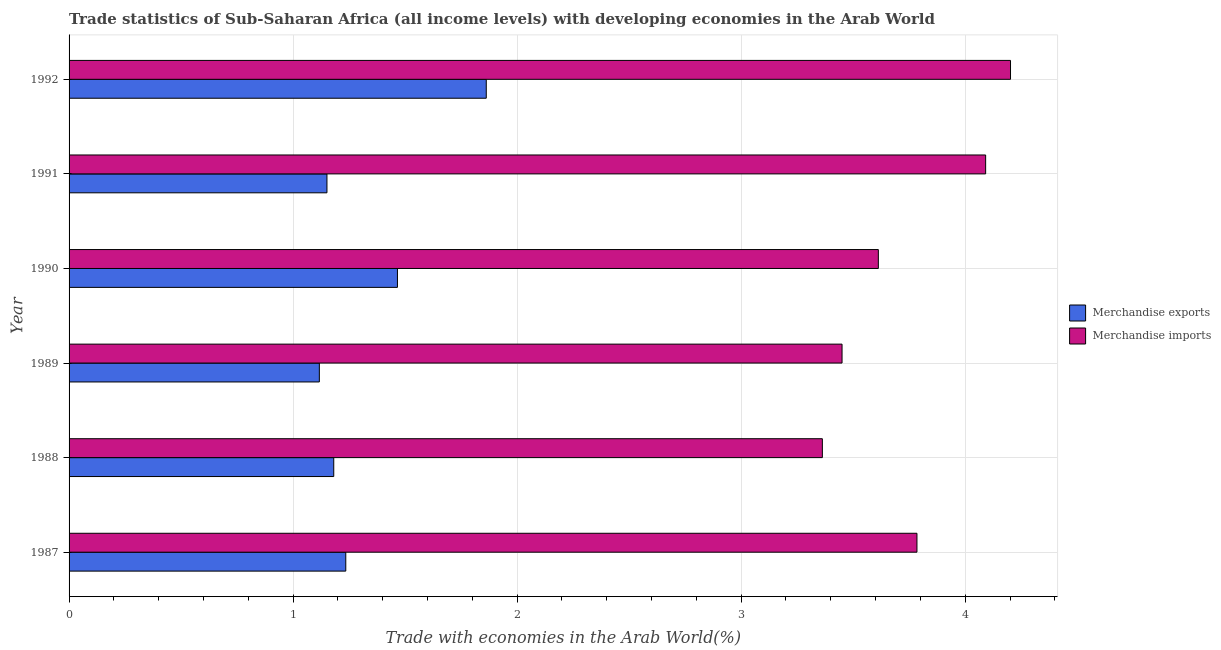How many groups of bars are there?
Your response must be concise. 6. Are the number of bars per tick equal to the number of legend labels?
Keep it short and to the point. Yes. How many bars are there on the 5th tick from the bottom?
Your response must be concise. 2. In how many cases, is the number of bars for a given year not equal to the number of legend labels?
Give a very brief answer. 0. What is the merchandise exports in 1988?
Make the answer very short. 1.18. Across all years, what is the maximum merchandise imports?
Your response must be concise. 4.2. Across all years, what is the minimum merchandise imports?
Make the answer very short. 3.36. What is the total merchandise imports in the graph?
Ensure brevity in your answer.  22.5. What is the difference between the merchandise imports in 1987 and that in 1988?
Provide a short and direct response. 0.42. What is the difference between the merchandise exports in 1990 and the merchandise imports in 1991?
Give a very brief answer. -2.63. What is the average merchandise exports per year?
Your answer should be compact. 1.33. In the year 1988, what is the difference between the merchandise imports and merchandise exports?
Your response must be concise. 2.18. In how many years, is the merchandise exports greater than 2.6 %?
Provide a succinct answer. 0. What is the ratio of the merchandise imports in 1987 to that in 1988?
Offer a terse response. 1.13. Is the merchandise imports in 1988 less than that in 1989?
Provide a short and direct response. Yes. Is the difference between the merchandise exports in 1987 and 1990 greater than the difference between the merchandise imports in 1987 and 1990?
Your answer should be compact. No. What is the difference between the highest and the second highest merchandise imports?
Offer a very short reply. 0.11. What is the difference between the highest and the lowest merchandise imports?
Ensure brevity in your answer.  0.84. What does the 2nd bar from the top in 1987 represents?
Offer a very short reply. Merchandise exports. What does the 2nd bar from the bottom in 1987 represents?
Ensure brevity in your answer.  Merchandise imports. How many bars are there?
Your answer should be very brief. 12. Are the values on the major ticks of X-axis written in scientific E-notation?
Make the answer very short. No. Does the graph contain any zero values?
Ensure brevity in your answer.  No. Does the graph contain grids?
Keep it short and to the point. Yes. How many legend labels are there?
Offer a terse response. 2. What is the title of the graph?
Offer a very short reply. Trade statistics of Sub-Saharan Africa (all income levels) with developing economies in the Arab World. What is the label or title of the X-axis?
Your response must be concise. Trade with economies in the Arab World(%). What is the label or title of the Y-axis?
Provide a short and direct response. Year. What is the Trade with economies in the Arab World(%) in Merchandise exports in 1987?
Make the answer very short. 1.24. What is the Trade with economies in the Arab World(%) in Merchandise imports in 1987?
Offer a terse response. 3.78. What is the Trade with economies in the Arab World(%) in Merchandise exports in 1988?
Your answer should be compact. 1.18. What is the Trade with economies in the Arab World(%) in Merchandise imports in 1988?
Offer a terse response. 3.36. What is the Trade with economies in the Arab World(%) in Merchandise exports in 1989?
Your response must be concise. 1.12. What is the Trade with economies in the Arab World(%) in Merchandise imports in 1989?
Offer a very short reply. 3.45. What is the Trade with economies in the Arab World(%) in Merchandise exports in 1990?
Your answer should be very brief. 1.47. What is the Trade with economies in the Arab World(%) in Merchandise imports in 1990?
Ensure brevity in your answer.  3.61. What is the Trade with economies in the Arab World(%) of Merchandise exports in 1991?
Give a very brief answer. 1.15. What is the Trade with economies in the Arab World(%) of Merchandise imports in 1991?
Provide a short and direct response. 4.09. What is the Trade with economies in the Arab World(%) in Merchandise exports in 1992?
Give a very brief answer. 1.86. What is the Trade with economies in the Arab World(%) in Merchandise imports in 1992?
Your answer should be very brief. 4.2. Across all years, what is the maximum Trade with economies in the Arab World(%) of Merchandise exports?
Make the answer very short. 1.86. Across all years, what is the maximum Trade with economies in the Arab World(%) of Merchandise imports?
Your answer should be very brief. 4.2. Across all years, what is the minimum Trade with economies in the Arab World(%) in Merchandise exports?
Provide a short and direct response. 1.12. Across all years, what is the minimum Trade with economies in the Arab World(%) of Merchandise imports?
Offer a very short reply. 3.36. What is the total Trade with economies in the Arab World(%) of Merchandise exports in the graph?
Your answer should be compact. 8.01. What is the total Trade with economies in the Arab World(%) in Merchandise imports in the graph?
Provide a succinct answer. 22.5. What is the difference between the Trade with economies in the Arab World(%) in Merchandise exports in 1987 and that in 1988?
Your answer should be very brief. 0.05. What is the difference between the Trade with economies in the Arab World(%) of Merchandise imports in 1987 and that in 1988?
Provide a succinct answer. 0.42. What is the difference between the Trade with economies in the Arab World(%) of Merchandise exports in 1987 and that in 1989?
Offer a terse response. 0.12. What is the difference between the Trade with economies in the Arab World(%) of Merchandise imports in 1987 and that in 1989?
Offer a very short reply. 0.33. What is the difference between the Trade with economies in the Arab World(%) of Merchandise exports in 1987 and that in 1990?
Offer a very short reply. -0.23. What is the difference between the Trade with economies in the Arab World(%) of Merchandise imports in 1987 and that in 1990?
Your answer should be compact. 0.17. What is the difference between the Trade with economies in the Arab World(%) of Merchandise exports in 1987 and that in 1991?
Keep it short and to the point. 0.08. What is the difference between the Trade with economies in the Arab World(%) of Merchandise imports in 1987 and that in 1991?
Your answer should be very brief. -0.31. What is the difference between the Trade with economies in the Arab World(%) of Merchandise exports in 1987 and that in 1992?
Your response must be concise. -0.63. What is the difference between the Trade with economies in the Arab World(%) of Merchandise imports in 1987 and that in 1992?
Your answer should be very brief. -0.42. What is the difference between the Trade with economies in the Arab World(%) of Merchandise exports in 1988 and that in 1989?
Offer a very short reply. 0.06. What is the difference between the Trade with economies in the Arab World(%) in Merchandise imports in 1988 and that in 1989?
Keep it short and to the point. -0.09. What is the difference between the Trade with economies in the Arab World(%) in Merchandise exports in 1988 and that in 1990?
Keep it short and to the point. -0.28. What is the difference between the Trade with economies in the Arab World(%) in Merchandise imports in 1988 and that in 1990?
Offer a very short reply. -0.25. What is the difference between the Trade with economies in the Arab World(%) in Merchandise exports in 1988 and that in 1991?
Keep it short and to the point. 0.03. What is the difference between the Trade with economies in the Arab World(%) in Merchandise imports in 1988 and that in 1991?
Provide a short and direct response. -0.73. What is the difference between the Trade with economies in the Arab World(%) of Merchandise exports in 1988 and that in 1992?
Your answer should be very brief. -0.68. What is the difference between the Trade with economies in the Arab World(%) of Merchandise imports in 1988 and that in 1992?
Ensure brevity in your answer.  -0.84. What is the difference between the Trade with economies in the Arab World(%) in Merchandise exports in 1989 and that in 1990?
Provide a short and direct response. -0.35. What is the difference between the Trade with economies in the Arab World(%) of Merchandise imports in 1989 and that in 1990?
Ensure brevity in your answer.  -0.16. What is the difference between the Trade with economies in the Arab World(%) of Merchandise exports in 1989 and that in 1991?
Provide a succinct answer. -0.03. What is the difference between the Trade with economies in the Arab World(%) in Merchandise imports in 1989 and that in 1991?
Your response must be concise. -0.64. What is the difference between the Trade with economies in the Arab World(%) of Merchandise exports in 1989 and that in 1992?
Your answer should be compact. -0.74. What is the difference between the Trade with economies in the Arab World(%) in Merchandise imports in 1989 and that in 1992?
Provide a succinct answer. -0.75. What is the difference between the Trade with economies in the Arab World(%) in Merchandise exports in 1990 and that in 1991?
Your answer should be very brief. 0.31. What is the difference between the Trade with economies in the Arab World(%) of Merchandise imports in 1990 and that in 1991?
Your answer should be very brief. -0.48. What is the difference between the Trade with economies in the Arab World(%) of Merchandise exports in 1990 and that in 1992?
Make the answer very short. -0.4. What is the difference between the Trade with economies in the Arab World(%) of Merchandise imports in 1990 and that in 1992?
Offer a terse response. -0.59. What is the difference between the Trade with economies in the Arab World(%) of Merchandise exports in 1991 and that in 1992?
Your response must be concise. -0.71. What is the difference between the Trade with economies in the Arab World(%) in Merchandise imports in 1991 and that in 1992?
Offer a very short reply. -0.11. What is the difference between the Trade with economies in the Arab World(%) of Merchandise exports in 1987 and the Trade with economies in the Arab World(%) of Merchandise imports in 1988?
Your answer should be very brief. -2.13. What is the difference between the Trade with economies in the Arab World(%) in Merchandise exports in 1987 and the Trade with economies in the Arab World(%) in Merchandise imports in 1989?
Offer a terse response. -2.22. What is the difference between the Trade with economies in the Arab World(%) of Merchandise exports in 1987 and the Trade with economies in the Arab World(%) of Merchandise imports in 1990?
Provide a short and direct response. -2.38. What is the difference between the Trade with economies in the Arab World(%) of Merchandise exports in 1987 and the Trade with economies in the Arab World(%) of Merchandise imports in 1991?
Provide a short and direct response. -2.86. What is the difference between the Trade with economies in the Arab World(%) in Merchandise exports in 1987 and the Trade with economies in the Arab World(%) in Merchandise imports in 1992?
Provide a short and direct response. -2.97. What is the difference between the Trade with economies in the Arab World(%) of Merchandise exports in 1988 and the Trade with economies in the Arab World(%) of Merchandise imports in 1989?
Keep it short and to the point. -2.27. What is the difference between the Trade with economies in the Arab World(%) of Merchandise exports in 1988 and the Trade with economies in the Arab World(%) of Merchandise imports in 1990?
Provide a short and direct response. -2.43. What is the difference between the Trade with economies in the Arab World(%) of Merchandise exports in 1988 and the Trade with economies in the Arab World(%) of Merchandise imports in 1991?
Ensure brevity in your answer.  -2.91. What is the difference between the Trade with economies in the Arab World(%) of Merchandise exports in 1988 and the Trade with economies in the Arab World(%) of Merchandise imports in 1992?
Your answer should be compact. -3.02. What is the difference between the Trade with economies in the Arab World(%) of Merchandise exports in 1989 and the Trade with economies in the Arab World(%) of Merchandise imports in 1990?
Provide a short and direct response. -2.5. What is the difference between the Trade with economies in the Arab World(%) in Merchandise exports in 1989 and the Trade with economies in the Arab World(%) in Merchandise imports in 1991?
Make the answer very short. -2.97. What is the difference between the Trade with economies in the Arab World(%) in Merchandise exports in 1989 and the Trade with economies in the Arab World(%) in Merchandise imports in 1992?
Your answer should be very brief. -3.09. What is the difference between the Trade with economies in the Arab World(%) in Merchandise exports in 1990 and the Trade with economies in the Arab World(%) in Merchandise imports in 1991?
Your answer should be very brief. -2.63. What is the difference between the Trade with economies in the Arab World(%) in Merchandise exports in 1990 and the Trade with economies in the Arab World(%) in Merchandise imports in 1992?
Provide a short and direct response. -2.74. What is the difference between the Trade with economies in the Arab World(%) in Merchandise exports in 1991 and the Trade with economies in the Arab World(%) in Merchandise imports in 1992?
Provide a succinct answer. -3.05. What is the average Trade with economies in the Arab World(%) in Merchandise exports per year?
Offer a very short reply. 1.34. What is the average Trade with economies in the Arab World(%) in Merchandise imports per year?
Your answer should be compact. 3.75. In the year 1987, what is the difference between the Trade with economies in the Arab World(%) in Merchandise exports and Trade with economies in the Arab World(%) in Merchandise imports?
Give a very brief answer. -2.55. In the year 1988, what is the difference between the Trade with economies in the Arab World(%) in Merchandise exports and Trade with economies in the Arab World(%) in Merchandise imports?
Give a very brief answer. -2.18. In the year 1989, what is the difference between the Trade with economies in the Arab World(%) of Merchandise exports and Trade with economies in the Arab World(%) of Merchandise imports?
Give a very brief answer. -2.33. In the year 1990, what is the difference between the Trade with economies in the Arab World(%) of Merchandise exports and Trade with economies in the Arab World(%) of Merchandise imports?
Your answer should be very brief. -2.15. In the year 1991, what is the difference between the Trade with economies in the Arab World(%) in Merchandise exports and Trade with economies in the Arab World(%) in Merchandise imports?
Your answer should be very brief. -2.94. In the year 1992, what is the difference between the Trade with economies in the Arab World(%) in Merchandise exports and Trade with economies in the Arab World(%) in Merchandise imports?
Keep it short and to the point. -2.34. What is the ratio of the Trade with economies in the Arab World(%) in Merchandise exports in 1987 to that in 1988?
Your response must be concise. 1.05. What is the ratio of the Trade with economies in the Arab World(%) of Merchandise imports in 1987 to that in 1988?
Keep it short and to the point. 1.13. What is the ratio of the Trade with economies in the Arab World(%) in Merchandise exports in 1987 to that in 1989?
Your answer should be compact. 1.11. What is the ratio of the Trade with economies in the Arab World(%) in Merchandise imports in 1987 to that in 1989?
Make the answer very short. 1.1. What is the ratio of the Trade with economies in the Arab World(%) in Merchandise exports in 1987 to that in 1990?
Provide a short and direct response. 0.84. What is the ratio of the Trade with economies in the Arab World(%) of Merchandise imports in 1987 to that in 1990?
Your answer should be very brief. 1.05. What is the ratio of the Trade with economies in the Arab World(%) in Merchandise exports in 1987 to that in 1991?
Provide a succinct answer. 1.07. What is the ratio of the Trade with economies in the Arab World(%) of Merchandise imports in 1987 to that in 1991?
Give a very brief answer. 0.93. What is the ratio of the Trade with economies in the Arab World(%) in Merchandise exports in 1987 to that in 1992?
Your answer should be compact. 0.66. What is the ratio of the Trade with economies in the Arab World(%) in Merchandise imports in 1987 to that in 1992?
Provide a succinct answer. 0.9. What is the ratio of the Trade with economies in the Arab World(%) of Merchandise exports in 1988 to that in 1989?
Keep it short and to the point. 1.06. What is the ratio of the Trade with economies in the Arab World(%) of Merchandise imports in 1988 to that in 1989?
Your answer should be very brief. 0.97. What is the ratio of the Trade with economies in the Arab World(%) in Merchandise exports in 1988 to that in 1990?
Make the answer very short. 0.81. What is the ratio of the Trade with economies in the Arab World(%) of Merchandise imports in 1988 to that in 1990?
Give a very brief answer. 0.93. What is the ratio of the Trade with economies in the Arab World(%) in Merchandise exports in 1988 to that in 1991?
Offer a very short reply. 1.03. What is the ratio of the Trade with economies in the Arab World(%) of Merchandise imports in 1988 to that in 1991?
Your answer should be very brief. 0.82. What is the ratio of the Trade with economies in the Arab World(%) of Merchandise exports in 1988 to that in 1992?
Give a very brief answer. 0.63. What is the ratio of the Trade with economies in the Arab World(%) in Merchandise imports in 1988 to that in 1992?
Keep it short and to the point. 0.8. What is the ratio of the Trade with economies in the Arab World(%) of Merchandise exports in 1989 to that in 1990?
Give a very brief answer. 0.76. What is the ratio of the Trade with economies in the Arab World(%) of Merchandise imports in 1989 to that in 1990?
Give a very brief answer. 0.96. What is the ratio of the Trade with economies in the Arab World(%) of Merchandise exports in 1989 to that in 1991?
Your answer should be compact. 0.97. What is the ratio of the Trade with economies in the Arab World(%) of Merchandise imports in 1989 to that in 1991?
Your answer should be very brief. 0.84. What is the ratio of the Trade with economies in the Arab World(%) of Merchandise exports in 1989 to that in 1992?
Give a very brief answer. 0.6. What is the ratio of the Trade with economies in the Arab World(%) of Merchandise imports in 1989 to that in 1992?
Provide a short and direct response. 0.82. What is the ratio of the Trade with economies in the Arab World(%) of Merchandise exports in 1990 to that in 1991?
Provide a short and direct response. 1.27. What is the ratio of the Trade with economies in the Arab World(%) of Merchandise imports in 1990 to that in 1991?
Offer a very short reply. 0.88. What is the ratio of the Trade with economies in the Arab World(%) in Merchandise exports in 1990 to that in 1992?
Offer a very short reply. 0.79. What is the ratio of the Trade with economies in the Arab World(%) in Merchandise imports in 1990 to that in 1992?
Keep it short and to the point. 0.86. What is the ratio of the Trade with economies in the Arab World(%) of Merchandise exports in 1991 to that in 1992?
Provide a short and direct response. 0.62. What is the ratio of the Trade with economies in the Arab World(%) of Merchandise imports in 1991 to that in 1992?
Give a very brief answer. 0.97. What is the difference between the highest and the second highest Trade with economies in the Arab World(%) of Merchandise exports?
Your answer should be compact. 0.4. What is the difference between the highest and the second highest Trade with economies in the Arab World(%) of Merchandise imports?
Ensure brevity in your answer.  0.11. What is the difference between the highest and the lowest Trade with economies in the Arab World(%) in Merchandise exports?
Your answer should be compact. 0.74. What is the difference between the highest and the lowest Trade with economies in the Arab World(%) of Merchandise imports?
Provide a succinct answer. 0.84. 